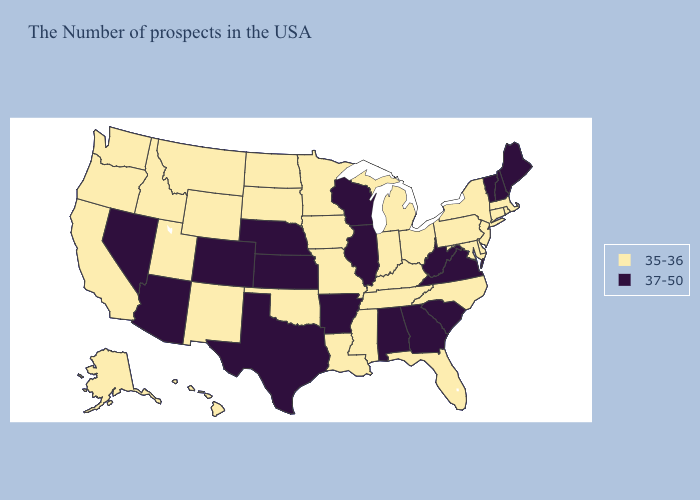Name the states that have a value in the range 37-50?
Concise answer only. Maine, New Hampshire, Vermont, Virginia, South Carolina, West Virginia, Georgia, Alabama, Wisconsin, Illinois, Arkansas, Kansas, Nebraska, Texas, Colorado, Arizona, Nevada. Among the states that border Louisiana , does Arkansas have the lowest value?
Be succinct. No. Name the states that have a value in the range 37-50?
Answer briefly. Maine, New Hampshire, Vermont, Virginia, South Carolina, West Virginia, Georgia, Alabama, Wisconsin, Illinois, Arkansas, Kansas, Nebraska, Texas, Colorado, Arizona, Nevada. Name the states that have a value in the range 35-36?
Answer briefly. Massachusetts, Rhode Island, Connecticut, New York, New Jersey, Delaware, Maryland, Pennsylvania, North Carolina, Ohio, Florida, Michigan, Kentucky, Indiana, Tennessee, Mississippi, Louisiana, Missouri, Minnesota, Iowa, Oklahoma, South Dakota, North Dakota, Wyoming, New Mexico, Utah, Montana, Idaho, California, Washington, Oregon, Alaska, Hawaii. What is the highest value in states that border Arkansas?
Write a very short answer. 37-50. Name the states that have a value in the range 35-36?
Give a very brief answer. Massachusetts, Rhode Island, Connecticut, New York, New Jersey, Delaware, Maryland, Pennsylvania, North Carolina, Ohio, Florida, Michigan, Kentucky, Indiana, Tennessee, Mississippi, Louisiana, Missouri, Minnesota, Iowa, Oklahoma, South Dakota, North Dakota, Wyoming, New Mexico, Utah, Montana, Idaho, California, Washington, Oregon, Alaska, Hawaii. Does Colorado have the lowest value in the USA?
Concise answer only. No. Does Alaska have a higher value than Missouri?
Concise answer only. No. Does Arkansas have the highest value in the South?
Quick response, please. Yes. What is the lowest value in the USA?
Quick response, please. 35-36. What is the value of Arkansas?
Short answer required. 37-50. Which states hav the highest value in the South?
Write a very short answer. Virginia, South Carolina, West Virginia, Georgia, Alabama, Arkansas, Texas. What is the value of Florida?
Answer briefly. 35-36. What is the lowest value in the West?
Be succinct. 35-36. Name the states that have a value in the range 35-36?
Write a very short answer. Massachusetts, Rhode Island, Connecticut, New York, New Jersey, Delaware, Maryland, Pennsylvania, North Carolina, Ohio, Florida, Michigan, Kentucky, Indiana, Tennessee, Mississippi, Louisiana, Missouri, Minnesota, Iowa, Oklahoma, South Dakota, North Dakota, Wyoming, New Mexico, Utah, Montana, Idaho, California, Washington, Oregon, Alaska, Hawaii. 